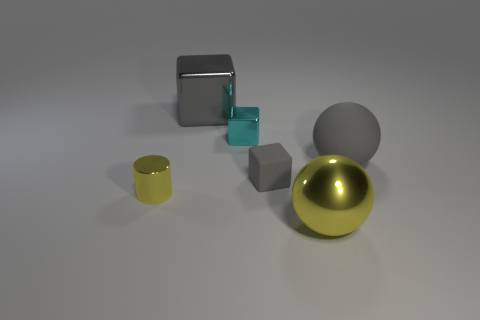What is the material of the cube that is to the left of the tiny matte object and in front of the big gray shiny thing?
Your answer should be compact. Metal. What is the size of the cyan shiny cube that is left of the large rubber object behind the small cube that is in front of the tiny cyan metallic thing?
Give a very brief answer. Small. There is a tiny cyan object; is its shape the same as the large object that is right of the metal ball?
Provide a succinct answer. No. What number of cubes are behind the large gray rubber sphere and right of the big block?
Provide a succinct answer. 1. What number of yellow things are either metallic spheres or blocks?
Ensure brevity in your answer.  1. Is the color of the large object on the right side of the big metallic sphere the same as the large shiny object that is behind the yellow metallic cylinder?
Keep it short and to the point. Yes. What is the color of the matte cube to the right of the tiny object on the left side of the thing behind the cyan thing?
Offer a very short reply. Gray. Are there any things that are in front of the sphere behind the large yellow sphere?
Your answer should be compact. Yes. Does the tiny metallic thing behind the matte ball have the same shape as the small gray rubber thing?
Make the answer very short. Yes. Are there any other things that have the same shape as the large gray shiny thing?
Your answer should be very brief. Yes. 